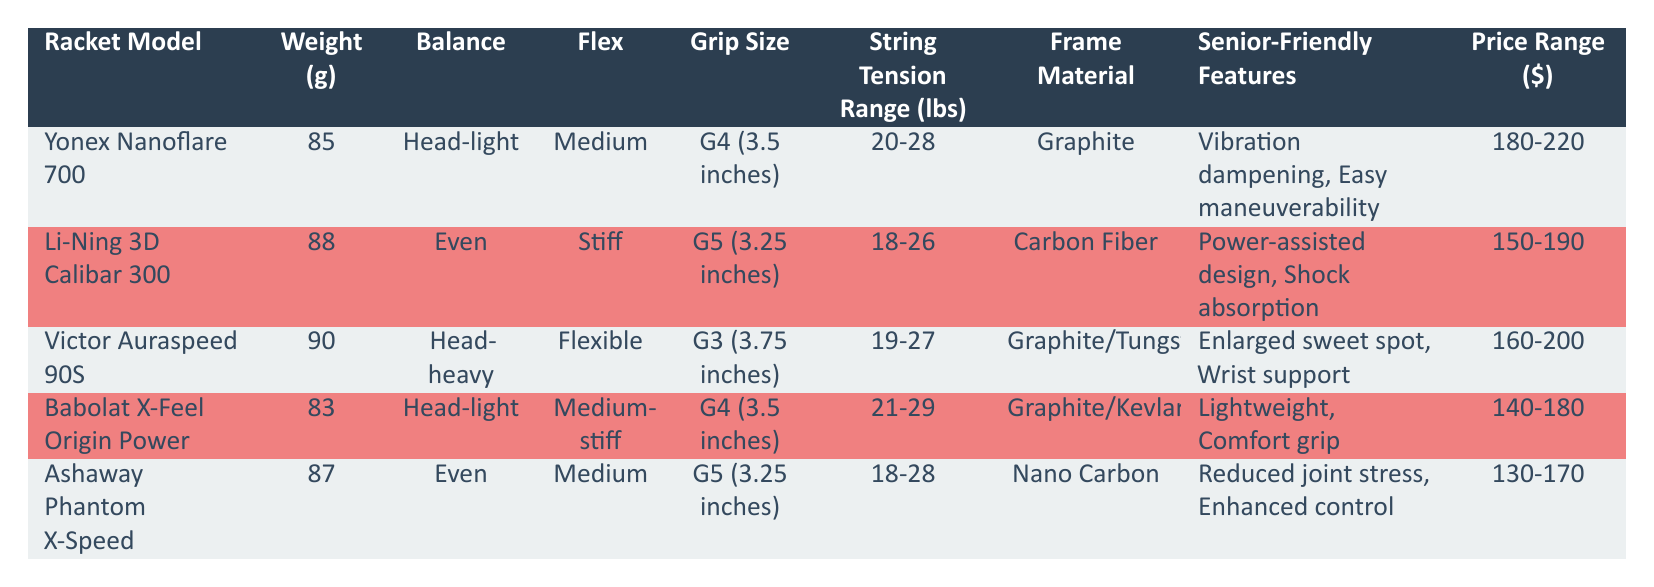What is the weight of the Yonex Nanoflare 700 racket? The weight of the Yonex Nanoflare 700 is listed directly in the table under the "Weight (g)" column, which shows 85 grams.
Answer: 85 g Which racket has the highest string tension range? To find the highest string tension range, we compare the ranges listed: Yonex Nanoflare 700 (20-28), Li-Ning 3D Calibar 300 (18-26), Victor Auraspeed 90S (19-27), Babolat X-Feel Origin Power (21-29), and Ashaway Phantom X-Speed (18-28). The Babolat X-Feel Origin Power has the highest range of 21-29 lbs.
Answer: Babolat X-Feel Origin Power Is the Li-Ning 3D Calibar 300 a head-heavy racket? The "Balance" column states that the Li-Ning 3D Calibar 300 has an "Even" balance, so it is not head-heavy.
Answer: No How many rackets have a grip size of G4? The rackets with a grip size of G4 are the Yonex Nanoflare 700 and Babolat X-Feel Origin Power. This makes a total of 2 rackets with that grip size.
Answer: 2 Which racket is the most affordable option? The price ranges of the rackets are as follows: Yonex Nanoflare 700 (180-220), Li-Ning 3D Calibar 300 (150-190), Victor Auraspeed 90S (160-200), Babolat X-Feel Origin Power (140-180), and Ashaway Phantom X-Speed (130-170). The Ashaway Phantom X-Speed has the lowest price range, starting at 130 dollars.
Answer: Ashaway Phantom X-Speed What is the difference in weight between the lightest and heaviest rackets? The lightest racket is Babolat X-Feel Origin Power at 83 g, and the heaviest is Victor Auraspeed 90S at 90 g. The difference in weight is calculated as 90 g - 83 g = 7 g.
Answer: 7 g Does the Victor Auraspeed 90S have a flexible frame? In the "Flex" column, it specifies that the Victor Auraspeed 90S is categorized as "Flexible." Therefore, the statement is true.
Answer: Yes What are the senior-friendly features of the Ashaway Phantom X-Speed racket? The "Senior-Friendly Features" column states that the Ashaway Phantom X-Speed offers "Reduced joint stress" and "Enhanced control."
Answer: Reduced joint stress, Enhanced control Which rackets are made of graphite as the frame material? The rackets made of graphite frame material are Yonex Nanoflare 700 and Victor Auraspeed 90S. This totals 2 rackets.
Answer: 2 